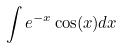Convert formula to latex. <formula><loc_0><loc_0><loc_500><loc_500>\int e ^ { - x } \cos ( x ) d x</formula> 